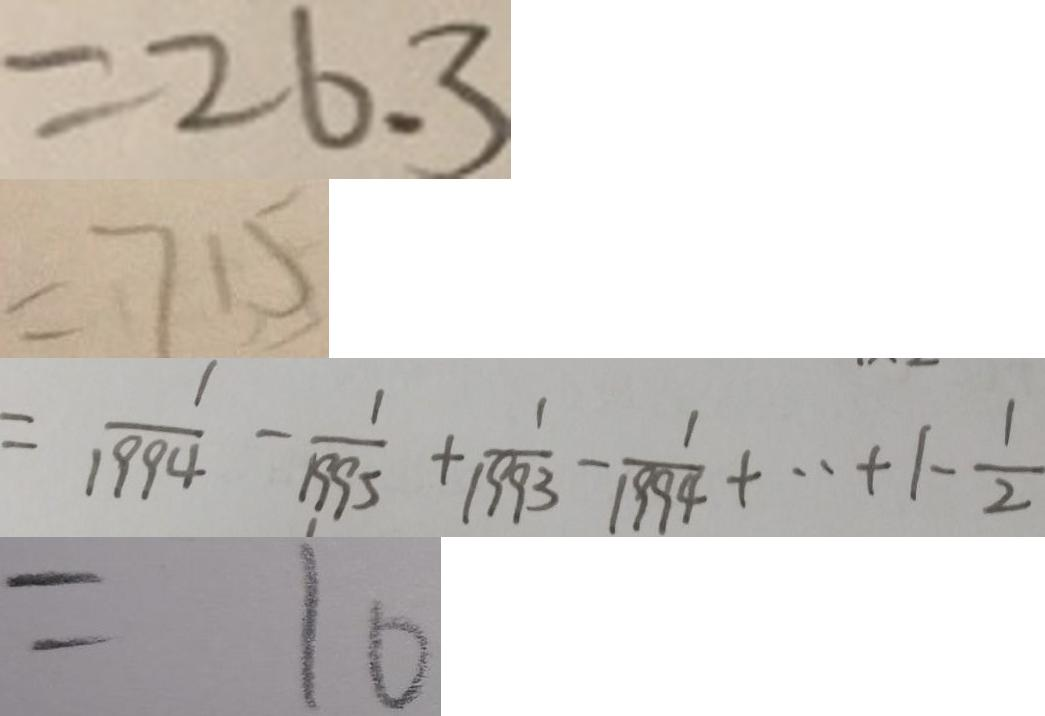<formula> <loc_0><loc_0><loc_500><loc_500>= 2 6 . 3 
 = 7 1 5 
 = \frac { 1 } { 1 9 9 4 } - \frac { 1 } { 1 9 9 5 } + \frac { 1 } { 1 9 9 3 } - \frac { 1 } { 1 9 9 4 } + \cdot + 1 - \frac { 1 } { 2 } 
 = 1 0</formula> 